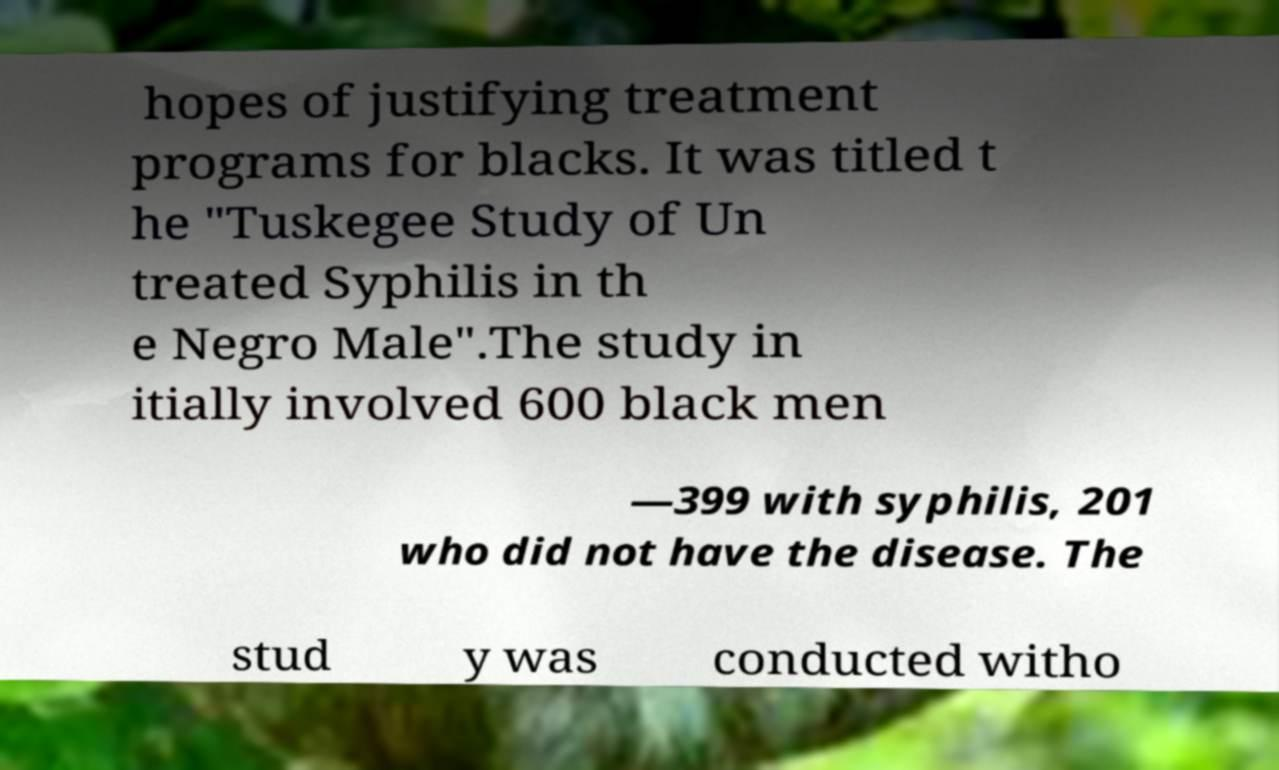There's text embedded in this image that I need extracted. Can you transcribe it verbatim? hopes of justifying treatment programs for blacks. It was titled t he "Tuskegee Study of Un treated Syphilis in th e Negro Male".The study in itially involved 600 black men —399 with syphilis, 201 who did not have the disease. The stud y was conducted witho 